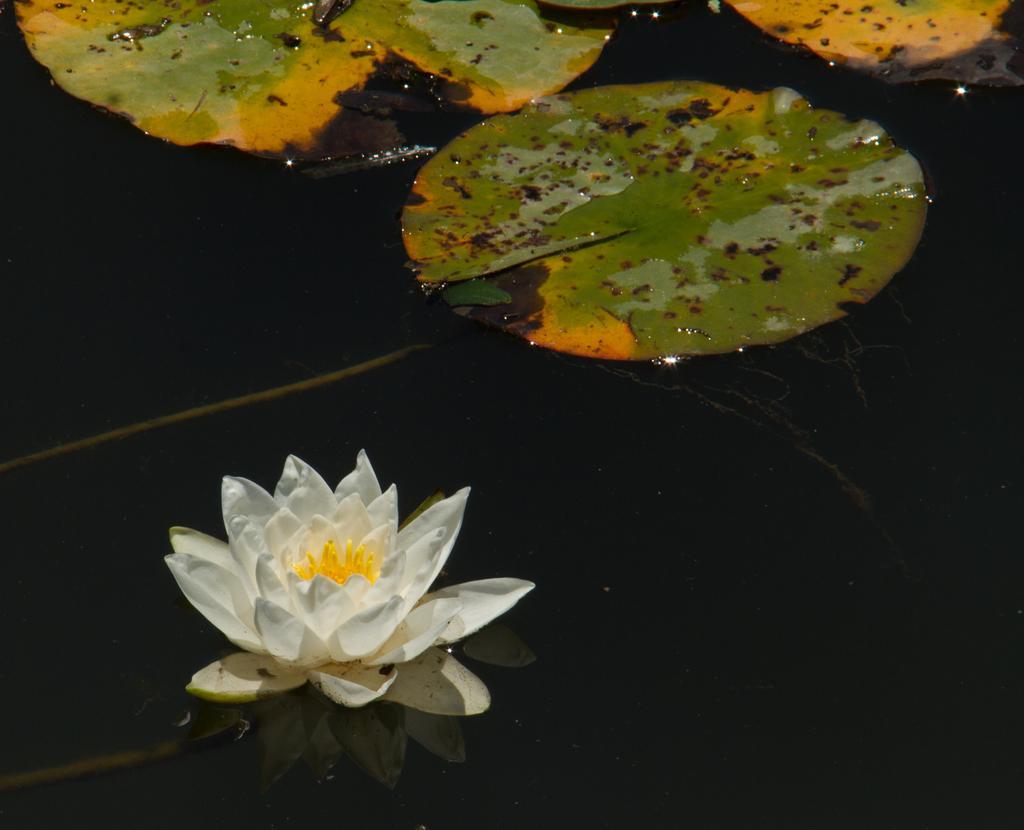In one or two sentences, can you explain what this image depicts? In this image we can see a lotus and some leaves in the water. 